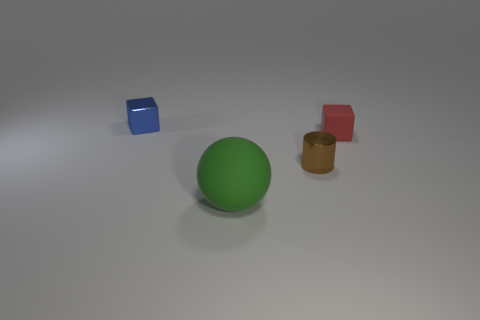Add 2 cyan spheres. How many objects exist? 6 Subtract all cylinders. How many objects are left? 3 Add 1 small brown shiny cylinders. How many small brown shiny cylinders exist? 2 Subtract 0 green cylinders. How many objects are left? 4 Subtract all gray balls. Subtract all blue cylinders. How many balls are left? 1 Subtract all tiny green things. Subtract all matte things. How many objects are left? 2 Add 2 small metallic blocks. How many small metallic blocks are left? 3 